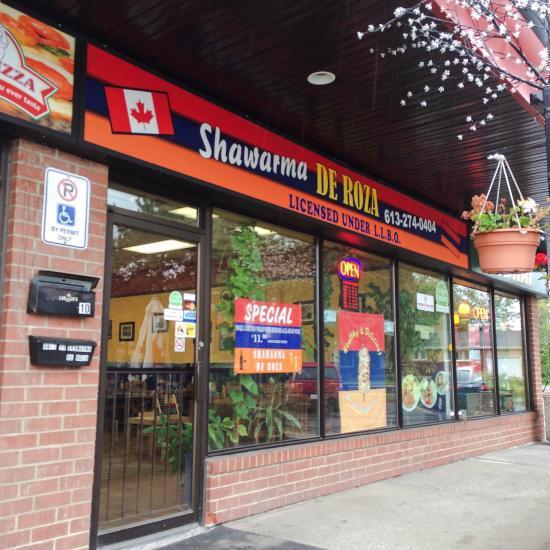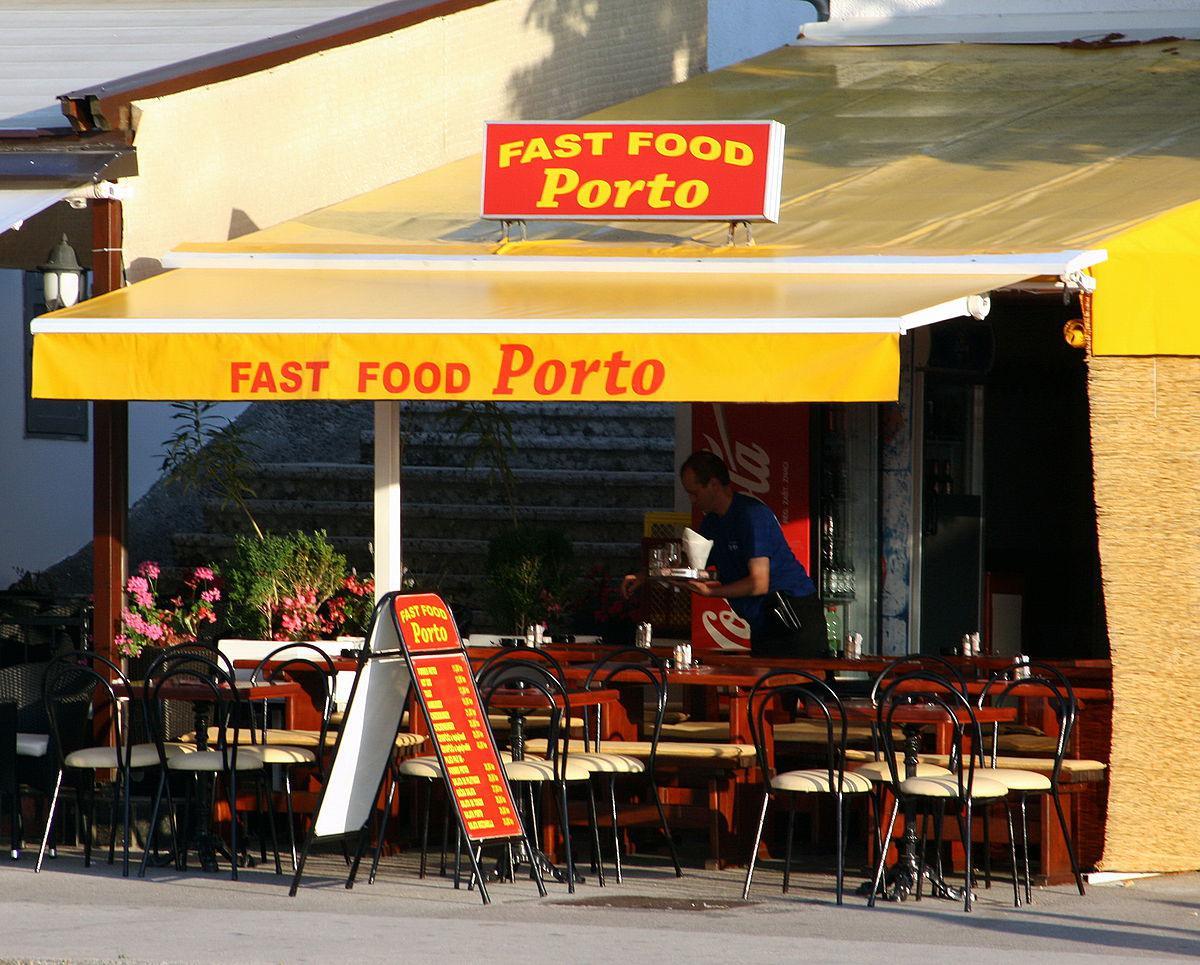The first image is the image on the left, the second image is the image on the right. Given the left and right images, does the statement "There are tables under the awning in one image." hold true? Answer yes or no. Yes. 